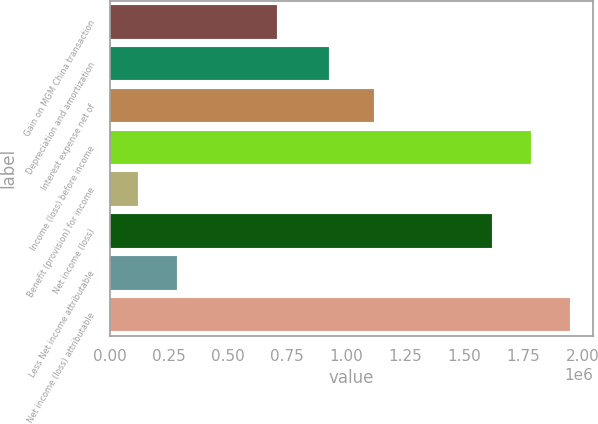<chart> <loc_0><loc_0><loc_500><loc_500><bar_chart><fcel>Gain on MGM China transaction<fcel>Depreciation and amortization<fcel>Interest expense net of<fcel>Income (loss) before income<fcel>Benefit (provision) for income<fcel>Net income (loss)<fcel>Less Net income attributable<fcel>Net income (loss) attributable<nl><fcel>708049<fcel>927697<fcel>1.11636e+06<fcel>1.78195e+06<fcel>117301<fcel>1.61691e+06<fcel>282340<fcel>1.94699e+06<nl></chart> 